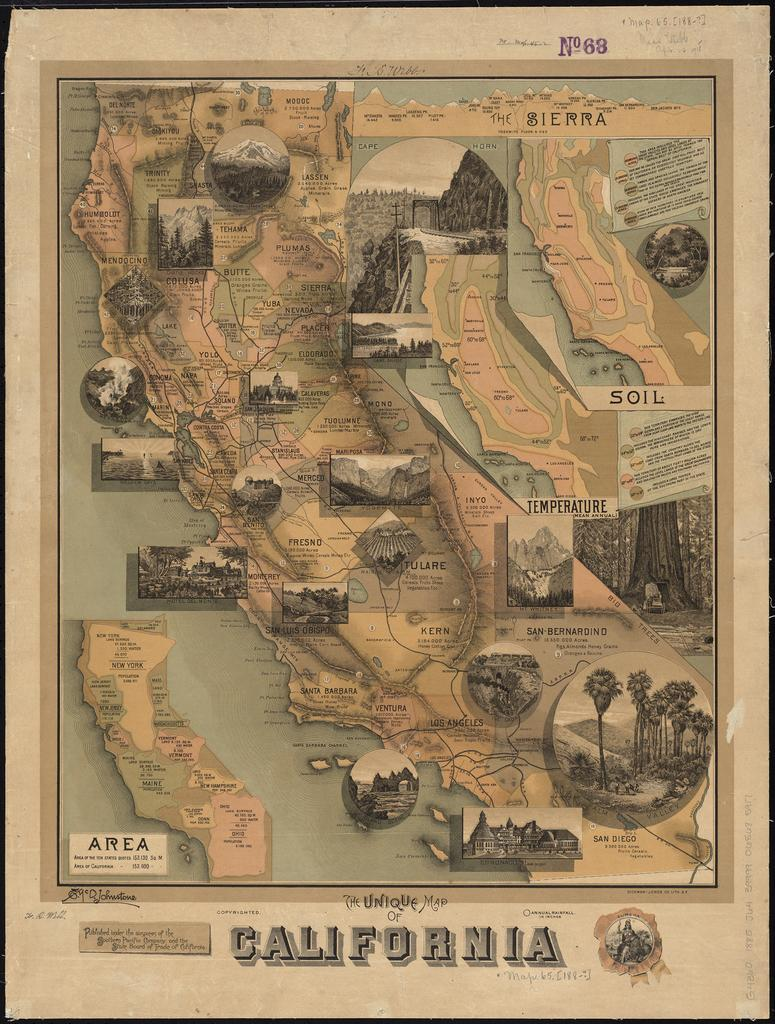Provide a one-sentence caption for the provided image. Map of California with the number 68 on top in purple. 